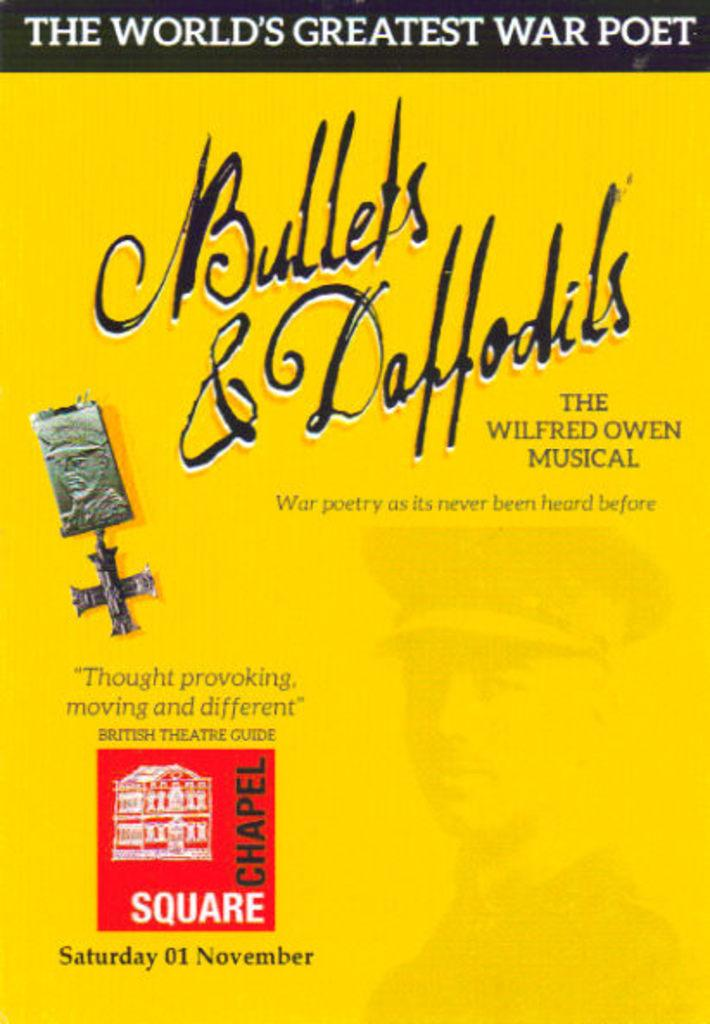<image>
Summarize the visual content of the image. Book cover for Bullets & Daffodils and the saying "The World's Greatest War Poet" on top. 